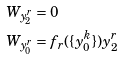Convert formula to latex. <formula><loc_0><loc_0><loc_500><loc_500>W _ { y _ { 2 } ^ { r } } & = 0 \\ W _ { y _ { 0 } ^ { r } } & = f _ { r } ( \{ y _ { 0 } ^ { k } \} ) y _ { 2 } ^ { r }</formula> 